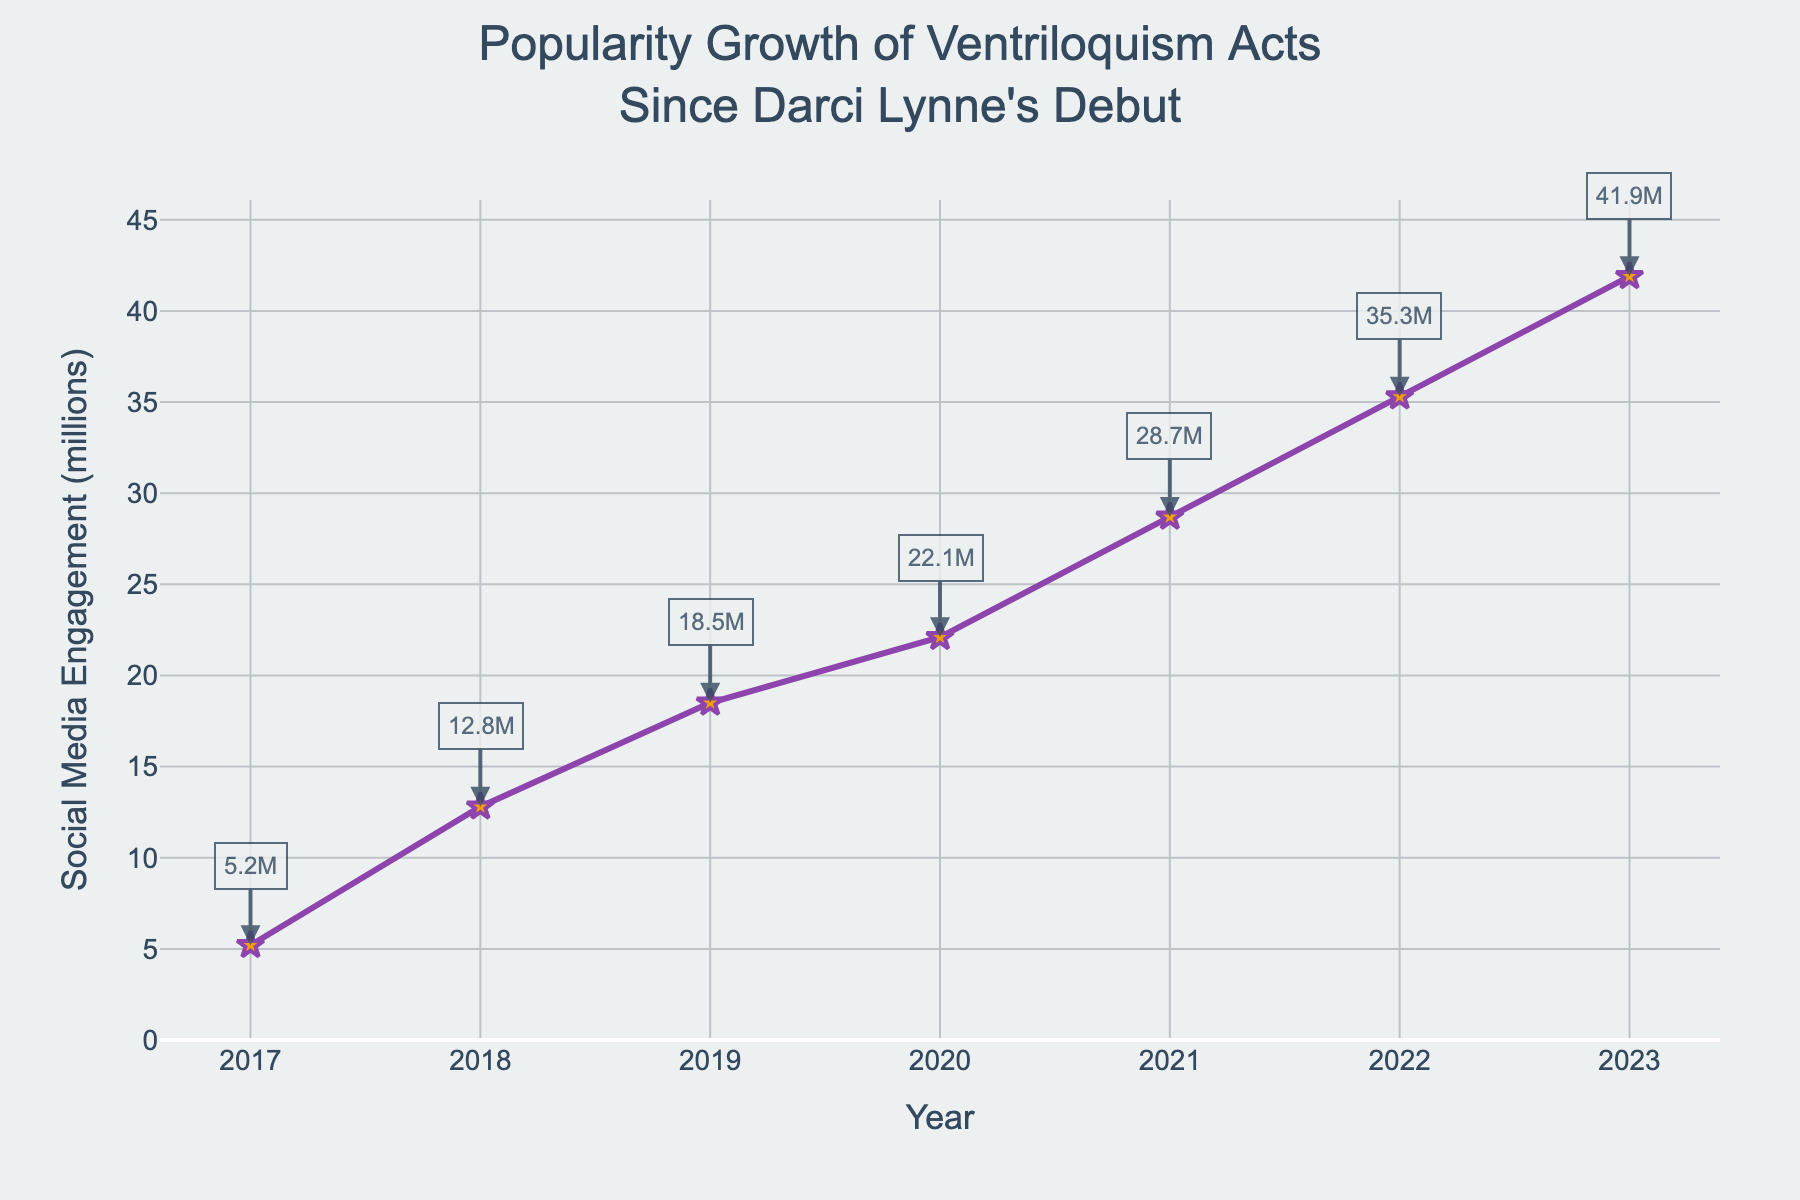What's the social media engagement in 2020? Referring to the figure, find the data point labeled with the year 2020. The annotation shows a value of 22.1 million.
Answer: 22.1 million In which year did the social media engagement first exceed 20 million? Look at the figure's annotations for each year to see when the engagement crossed 20 million. The value exceeds 20 million in 2020.
Answer: 2020 By how much did the social media engagement increase from 2018 to 2022? The engagement in 2018 is 12.8 million, and in 2022 it is 35.3 million. The increase is calculated as 35.3 - 12.8.
Answer: 22.5 million Which year saw the highest increase in social media engagement compared to the previous year? Check the increments between each successive year: 2018-2017 (12.8-5.2 = 7.6), 2019-2018 (18.5-12.8 = 5.7), 2020-2019 (22.1-18.5 = 3.6), 2021-2020 (28.7-22.1 = 6.6), 2022-2021 (35.3-28.7 = 6.6), 2023-2022 (41.9-35.3 = 6.6). The largest increase is in the year 2018.
Answer: 2018 How many years did it take for the social media engagement to grow from 5.2 million to over 40 million? The engagement was 5.2 million in 2017 and exceeded 40 million by 2023. Calculate the number of years from 2017 to 2023.
Answer: 6 years What's the average yearly growth in social media engagement from 2017 to 2023? Calculate the total increase from 2017 (5.2 million) to 2023 (41.9 million), which is 41.9 - 5.2 = 36.7 million. Then, divide this by the number of years (2023 - 2017 = 6 years).
Answer: 6.12 million per year Compare the social media engagements of 2019 and 2021. Which year had higher engagement and by how much? The engagement in 2019 is 18.5 million and in 2021 is 28.7 million. The difference is 28.7 - 18.5.
Answer: 2021 by 10.2 million What is the total social media engagement for all the years combined? Sum the engagement values for all years: 5.2 + 12.8 + 18.5 + 22.1 + 28.7 + 35.3 + 41.9.
Answer: 164.5 million What's the median social media engagement from 2017 to 2023? List the values in order: 5.2, 12.8, 18.5, 22.1, 28.7, 35.3, 41.9. The median is the middle value.
Answer: 22.1 million What color and size are the markers on the line chart? Look at the visual attributes of the plot. The markers are yellow and appear as stars which are generally visually distinct.
Answer: Yellow and star-shaped 